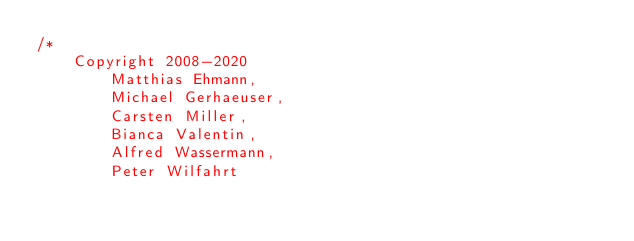Convert code to text. <code><loc_0><loc_0><loc_500><loc_500><_CSS_>/*
    Copyright 2008-2020
        Matthias Ehmann,
        Michael Gerhaeuser,
        Carsten Miller,
        Bianca Valentin,
        Alfred Wassermann,
        Peter Wilfahrt
</code> 